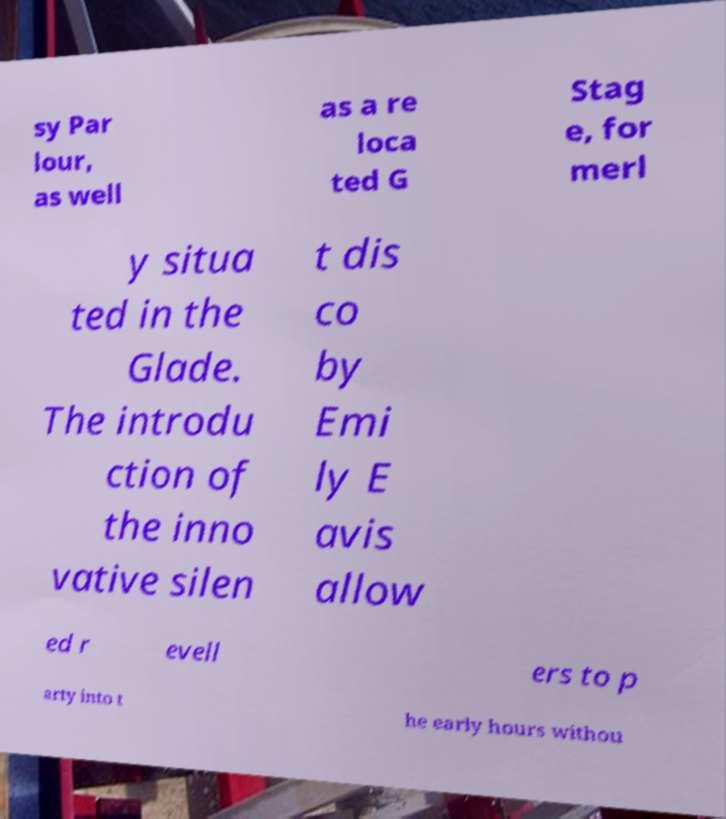I need the written content from this picture converted into text. Can you do that? sy Par lour, as well as a re loca ted G Stag e, for merl y situa ted in the Glade. The introdu ction of the inno vative silen t dis co by Emi ly E avis allow ed r evell ers to p arty into t he early hours withou 